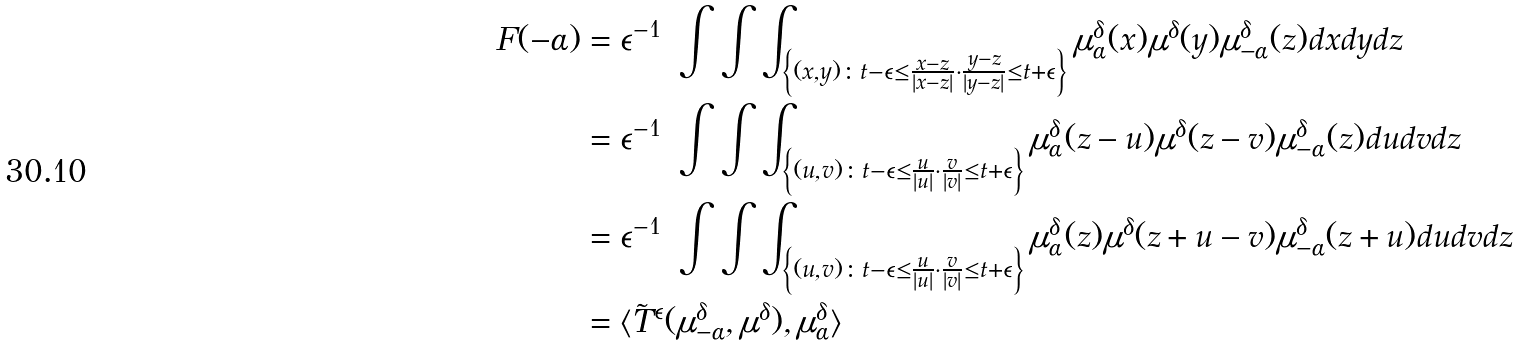<formula> <loc_0><loc_0><loc_500><loc_500>F ( - \alpha ) & = \epsilon ^ { - 1 } \ \int \int \int _ { \left \{ ( x , y ) \colon t - \epsilon \leq \frac { x - z } { | x - z | } \cdot \frac { y - z } { | y - z | } \leq t + \epsilon \right \} } \mu _ { \alpha } ^ { \delta } ( x ) \mu ^ { \delta } ( y ) \mu _ { - \alpha } ^ { \delta } ( z ) d x d y d z \\ & = \epsilon ^ { - 1 } \ \int \int \int _ { \left \{ ( u , v ) \colon t - \epsilon \leq \frac { u } { | u | } \cdot \frac { v } { | v | } \leq t + \epsilon \right \} } \mu _ { \alpha } ^ { \delta } ( z - u ) \mu ^ { \delta } ( z - v ) \mu _ { - \alpha } ^ { \delta } ( z ) d u d v d z \\ & = \epsilon ^ { - 1 } \ \int \int \int _ { \left \{ ( u , v ) \colon t - \epsilon \leq \frac { u } { | u | } \cdot \frac { v } { | v | } \leq t + \epsilon \right \} } \mu _ { \alpha } ^ { \delta } ( z ) \mu ^ { \delta } ( z + u - v ) \mu _ { - \alpha } ^ { \delta } ( z + u ) d u d v d z \\ & = \langle \tilde { T } ^ { \epsilon } ( \mu _ { - \alpha } ^ { \delta } , \mu ^ { \delta } ) , \mu _ { \alpha } ^ { \delta } \rangle</formula> 